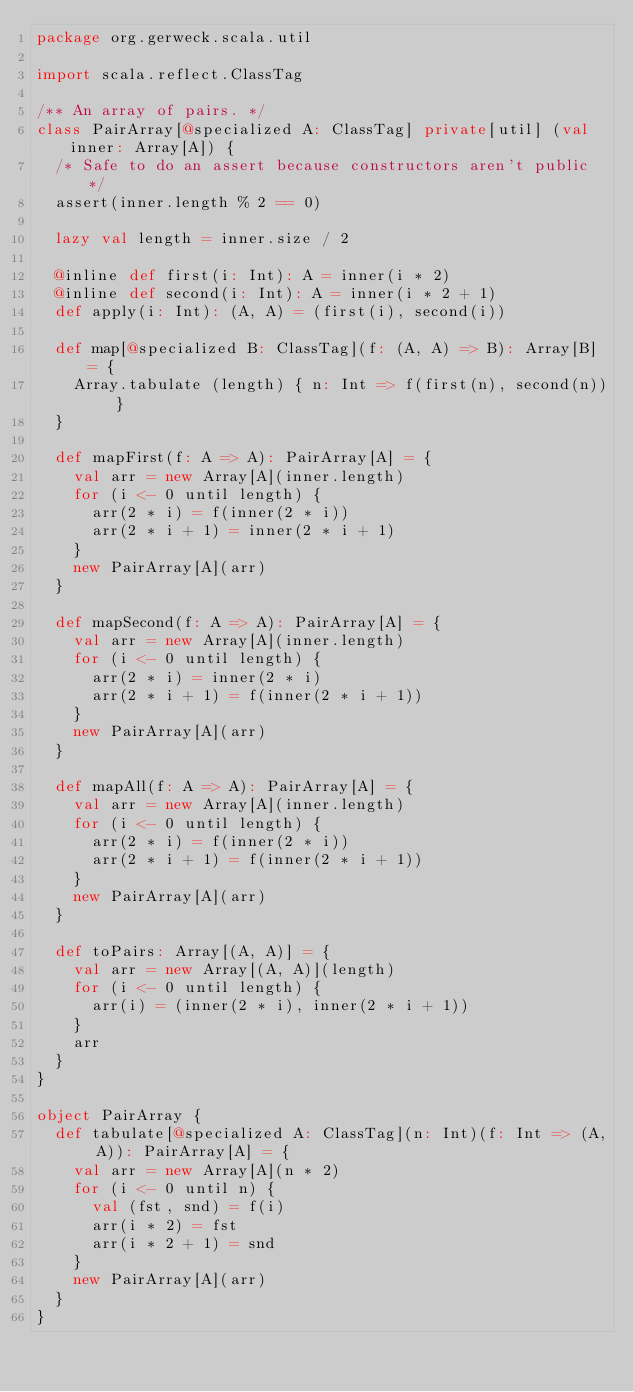Convert code to text. <code><loc_0><loc_0><loc_500><loc_500><_Scala_>package org.gerweck.scala.util

import scala.reflect.ClassTag

/** An array of pairs. */
class PairArray[@specialized A: ClassTag] private[util] (val inner: Array[A]) {
  /* Safe to do an assert because constructors aren't public */
  assert(inner.length % 2 == 0)

  lazy val length = inner.size / 2

  @inline def first(i: Int): A = inner(i * 2)
  @inline def second(i: Int): A = inner(i * 2 + 1)
  def apply(i: Int): (A, A) = (first(i), second(i))

  def map[@specialized B: ClassTag](f: (A, A) => B): Array[B] = {
    Array.tabulate (length) { n: Int => f(first(n), second(n)) }
  }

  def mapFirst(f: A => A): PairArray[A] = {
    val arr = new Array[A](inner.length)
    for (i <- 0 until length) {
      arr(2 * i) = f(inner(2 * i))
      arr(2 * i + 1) = inner(2 * i + 1)
    }
    new PairArray[A](arr)
  }

  def mapSecond(f: A => A): PairArray[A] = {
    val arr = new Array[A](inner.length)
    for (i <- 0 until length) {
      arr(2 * i) = inner(2 * i)
      arr(2 * i + 1) = f(inner(2 * i + 1))
    }
    new PairArray[A](arr)
  }

  def mapAll(f: A => A): PairArray[A] = {
    val arr = new Array[A](inner.length)
    for (i <- 0 until length) {
      arr(2 * i) = f(inner(2 * i))
      arr(2 * i + 1) = f(inner(2 * i + 1))
    }
    new PairArray[A](arr)
  }

  def toPairs: Array[(A, A)] = {
    val arr = new Array[(A, A)](length)
    for (i <- 0 until length) {
      arr(i) = (inner(2 * i), inner(2 * i + 1))
    }
    arr
  }
}

object PairArray {
  def tabulate[@specialized A: ClassTag](n: Int)(f: Int => (A, A)): PairArray[A] = {
    val arr = new Array[A](n * 2)
    for (i <- 0 until n) {
      val (fst, snd) = f(i)
      arr(i * 2) = fst
      arr(i * 2 + 1) = snd
    }
    new PairArray[A](arr)
  }
}
</code> 